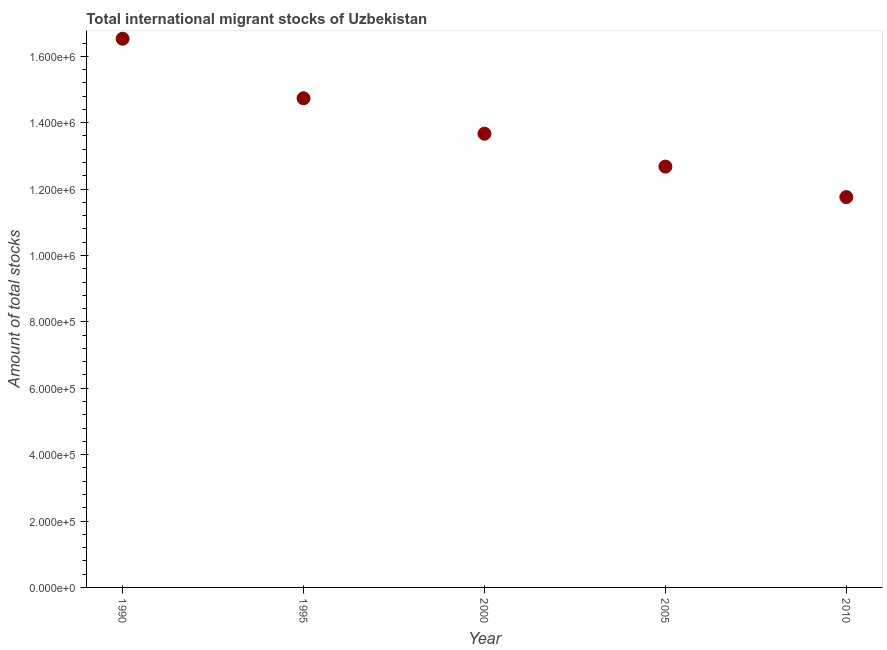What is the total number of international migrant stock in 2000?
Offer a terse response. 1.37e+06. Across all years, what is the maximum total number of international migrant stock?
Your answer should be very brief. 1.65e+06. Across all years, what is the minimum total number of international migrant stock?
Offer a terse response. 1.18e+06. In which year was the total number of international migrant stock maximum?
Your response must be concise. 1990. In which year was the total number of international migrant stock minimum?
Offer a terse response. 2010. What is the sum of the total number of international migrant stock?
Your response must be concise. 6.94e+06. What is the difference between the total number of international migrant stock in 2000 and 2005?
Your answer should be very brief. 9.91e+04. What is the average total number of international migrant stock per year?
Ensure brevity in your answer.  1.39e+06. What is the median total number of international migrant stock?
Give a very brief answer. 1.37e+06. In how many years, is the total number of international migrant stock greater than 1360000 ?
Ensure brevity in your answer.  3. What is the ratio of the total number of international migrant stock in 2005 to that in 2010?
Your answer should be very brief. 1.08. Is the total number of international migrant stock in 1990 less than that in 2000?
Your answer should be compact. No. Is the difference between the total number of international migrant stock in 1995 and 2010 greater than the difference between any two years?
Offer a terse response. No. What is the difference between the highest and the second highest total number of international migrant stock?
Your response must be concise. 1.79e+05. What is the difference between the highest and the lowest total number of international migrant stock?
Offer a very short reply. 4.77e+05. In how many years, is the total number of international migrant stock greater than the average total number of international migrant stock taken over all years?
Provide a succinct answer. 2. Does the total number of international migrant stock monotonically increase over the years?
Keep it short and to the point. No. How many dotlines are there?
Ensure brevity in your answer.  1. How many years are there in the graph?
Give a very brief answer. 5. What is the difference between two consecutive major ticks on the Y-axis?
Offer a terse response. 2.00e+05. Are the values on the major ticks of Y-axis written in scientific E-notation?
Ensure brevity in your answer.  Yes. What is the title of the graph?
Ensure brevity in your answer.  Total international migrant stocks of Uzbekistan. What is the label or title of the Y-axis?
Your answer should be compact. Amount of total stocks. What is the Amount of total stocks in 1990?
Keep it short and to the point. 1.65e+06. What is the Amount of total stocks in 1995?
Offer a terse response. 1.47e+06. What is the Amount of total stocks in 2000?
Ensure brevity in your answer.  1.37e+06. What is the Amount of total stocks in 2005?
Your response must be concise. 1.27e+06. What is the Amount of total stocks in 2010?
Make the answer very short. 1.18e+06. What is the difference between the Amount of total stocks in 1990 and 1995?
Your answer should be compact. 1.79e+05. What is the difference between the Amount of total stocks in 1990 and 2000?
Your answer should be very brief. 2.86e+05. What is the difference between the Amount of total stocks in 1990 and 2005?
Make the answer very short. 3.85e+05. What is the difference between the Amount of total stocks in 1990 and 2010?
Your response must be concise. 4.77e+05. What is the difference between the Amount of total stocks in 1995 and 2000?
Offer a very short reply. 1.07e+05. What is the difference between the Amount of total stocks in 1995 and 2005?
Provide a succinct answer. 2.06e+05. What is the difference between the Amount of total stocks in 1995 and 2010?
Offer a very short reply. 2.98e+05. What is the difference between the Amount of total stocks in 2000 and 2005?
Your answer should be very brief. 9.91e+04. What is the difference between the Amount of total stocks in 2000 and 2010?
Provide a succinct answer. 1.91e+05. What is the difference between the Amount of total stocks in 2005 and 2010?
Make the answer very short. 9.19e+04. What is the ratio of the Amount of total stocks in 1990 to that in 1995?
Your answer should be very brief. 1.12. What is the ratio of the Amount of total stocks in 1990 to that in 2000?
Keep it short and to the point. 1.21. What is the ratio of the Amount of total stocks in 1990 to that in 2005?
Offer a terse response. 1.3. What is the ratio of the Amount of total stocks in 1990 to that in 2010?
Provide a succinct answer. 1.41. What is the ratio of the Amount of total stocks in 1995 to that in 2000?
Make the answer very short. 1.08. What is the ratio of the Amount of total stocks in 1995 to that in 2005?
Provide a short and direct response. 1.16. What is the ratio of the Amount of total stocks in 1995 to that in 2010?
Provide a succinct answer. 1.25. What is the ratio of the Amount of total stocks in 2000 to that in 2005?
Offer a terse response. 1.08. What is the ratio of the Amount of total stocks in 2000 to that in 2010?
Offer a terse response. 1.16. What is the ratio of the Amount of total stocks in 2005 to that in 2010?
Give a very brief answer. 1.08. 